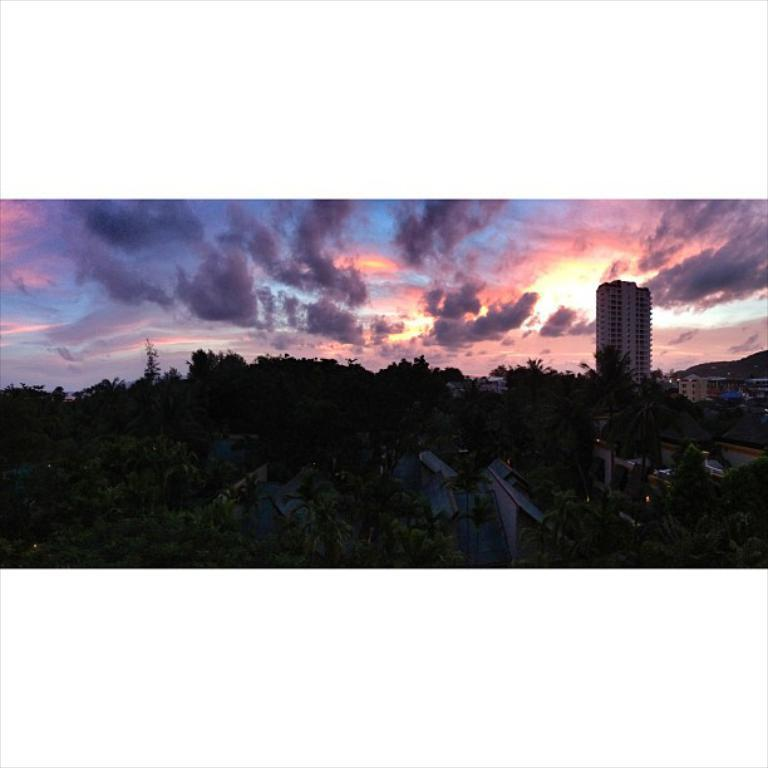What type of structure is the main subject of the image? There is a tower building in the image. What other types of structures are present in the image? There are houses in the image. What natural elements can be seen in the image? There are trees in the image. What is visible in the sky in the image? There are clouds in the sky in the image. What month is it in the image? The month cannot be determined from the image, as there is no information about the time of year. Can you see a pig in the image? No, there is no pig present in the image. 